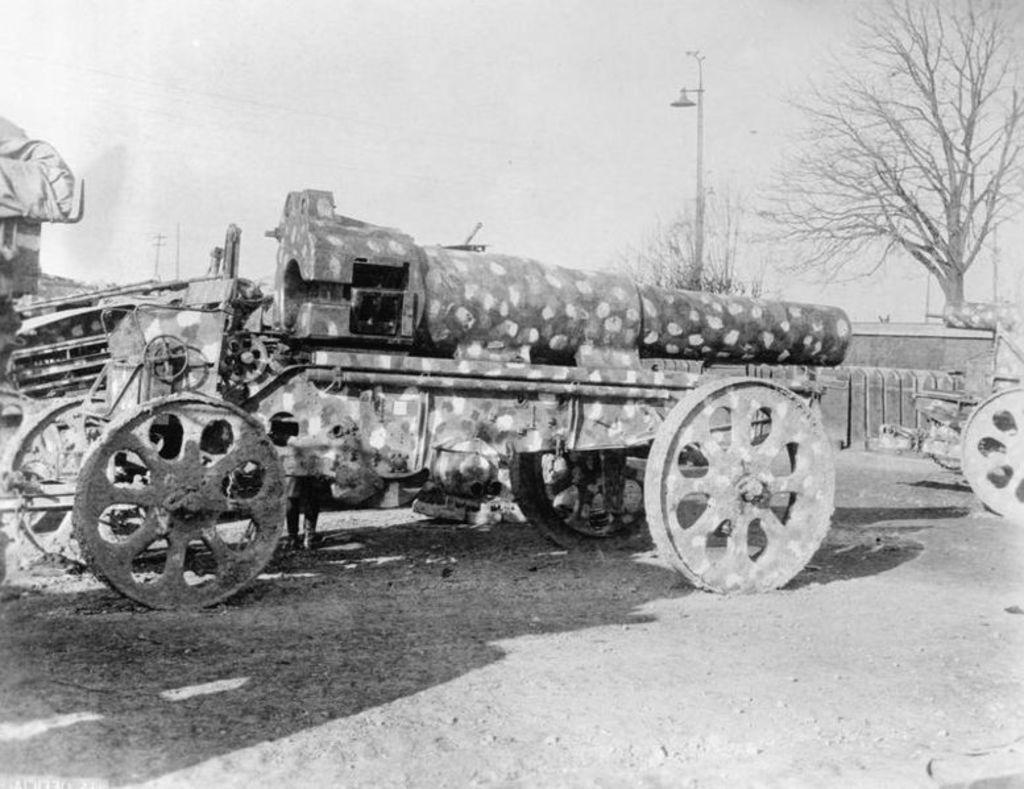What is the main subject of the image? There is a weapon on a vehicle in the image. What can be seen in the left corner of the image? There are other objects in the left corner of the image. What is located in the right corner of the image? There is a tree and a pole in the right corner of the image. What else can be seen in the right corner of the image? There are other objects in the right corner of the image. What type of toy can be seen in the image? There is no toy present in the image. Can you tell me which parent is depicted in the image? There are no people, including parents, present in the image. 